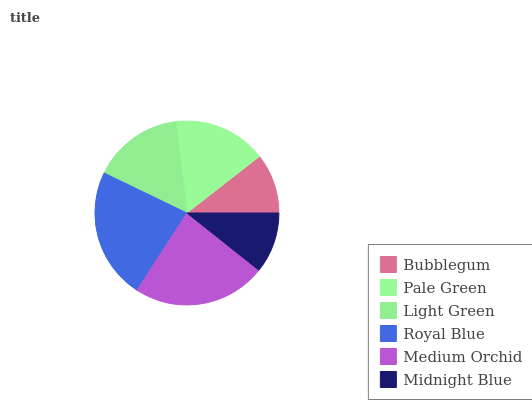Is Bubblegum the minimum?
Answer yes or no. Yes. Is Medium Orchid the maximum?
Answer yes or no. Yes. Is Pale Green the minimum?
Answer yes or no. No. Is Pale Green the maximum?
Answer yes or no. No. Is Pale Green greater than Bubblegum?
Answer yes or no. Yes. Is Bubblegum less than Pale Green?
Answer yes or no. Yes. Is Bubblegum greater than Pale Green?
Answer yes or no. No. Is Pale Green less than Bubblegum?
Answer yes or no. No. Is Pale Green the high median?
Answer yes or no. Yes. Is Light Green the low median?
Answer yes or no. Yes. Is Midnight Blue the high median?
Answer yes or no. No. Is Royal Blue the low median?
Answer yes or no. No. 